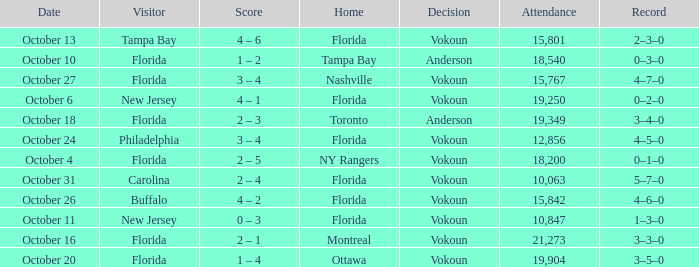What was the score on October 13? 4 – 6. 